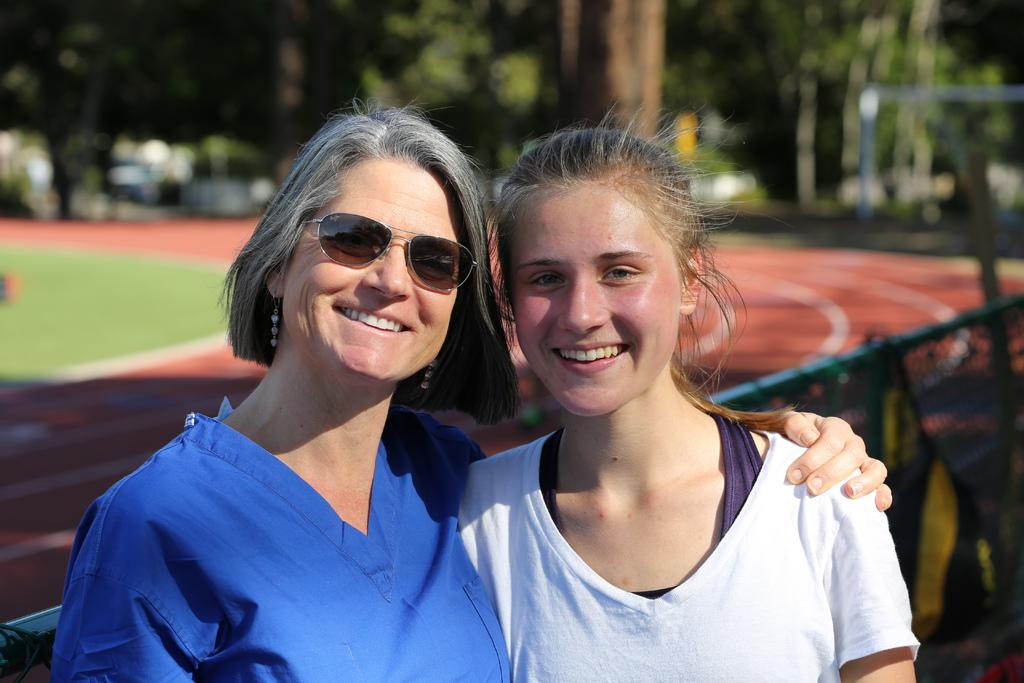How many women are in the image? There are two women in the image. What are the women doing in the image? The women are standing and holding each other. What is visible beneath the women's feet in the image? There is a ground visible in the image. What type of barrier can be seen in the image? There is a fence in the image. What type of vegetation is present in the image? There are trees in the image. What time of day is it in the image, as indicated by the hour on a clock? There is no clock visible in the image, so it is not possible to determine the time of day. 